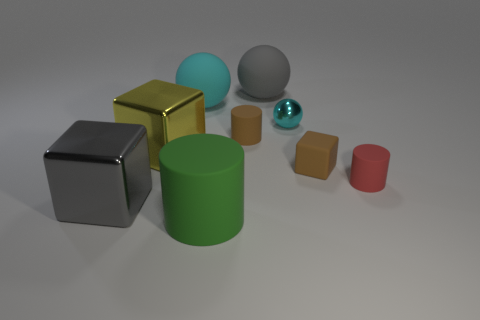Subtract all large cylinders. How many cylinders are left? 2 Add 1 gray metal cubes. How many objects exist? 10 Subtract all yellow cubes. How many cubes are left? 2 Subtract all blocks. How many objects are left? 6 Subtract 2 cubes. How many cubes are left? 1 Subtract all brown blocks. Subtract all green cylinders. How many blocks are left? 2 Subtract all brown balls. How many brown cubes are left? 1 Subtract all big green objects. Subtract all tiny things. How many objects are left? 4 Add 2 metallic things. How many metallic things are left? 5 Add 1 gray rubber things. How many gray rubber things exist? 2 